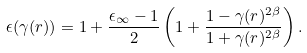<formula> <loc_0><loc_0><loc_500><loc_500>\epsilon ( \gamma ( { r } ) ) = 1 + \frac { \epsilon _ { \infty } - 1 } { 2 } \left ( 1 + \frac { 1 - \gamma ( { r } ) ^ { 2 \beta } } { 1 + \gamma ( { r } ) ^ { 2 \beta } } \right ) .</formula> 